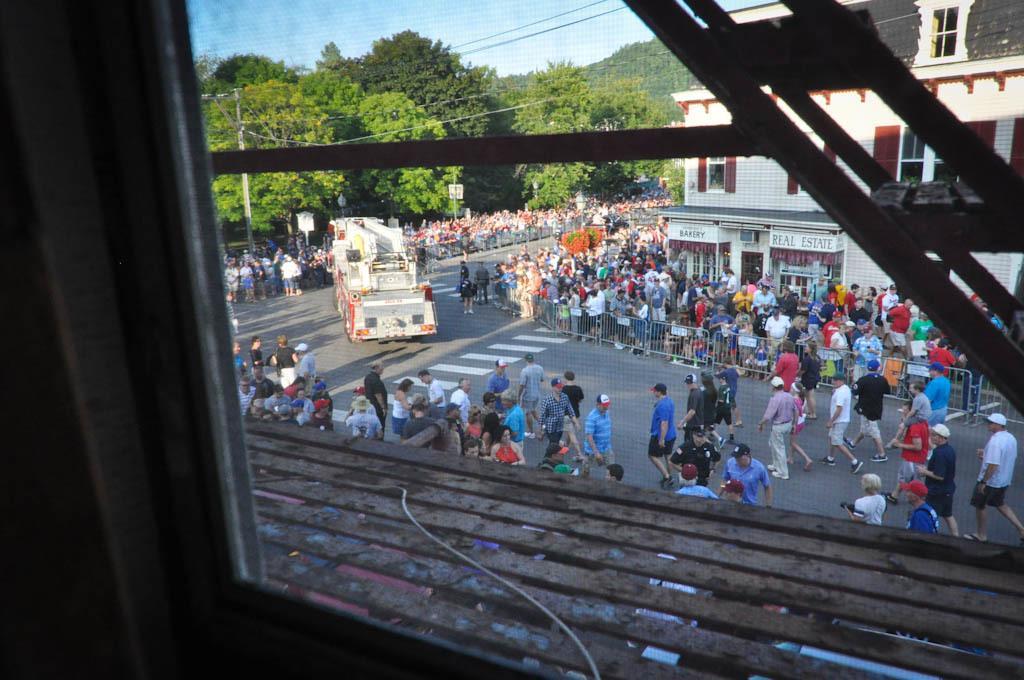Can you describe this image briefly? In this image there is a road on which there are so many people walking on it. In the middle there is a lorry. There are so many people standing beside the fence. Behind them there are buildings. On the left side there are trees in the background. At the bottom there is a wooden floor. It looks like a window. 